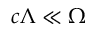<formula> <loc_0><loc_0><loc_500><loc_500>c \Lambda \ll \Omega</formula> 